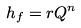<formula> <loc_0><loc_0><loc_500><loc_500>h _ { f } = r Q ^ { n }</formula> 